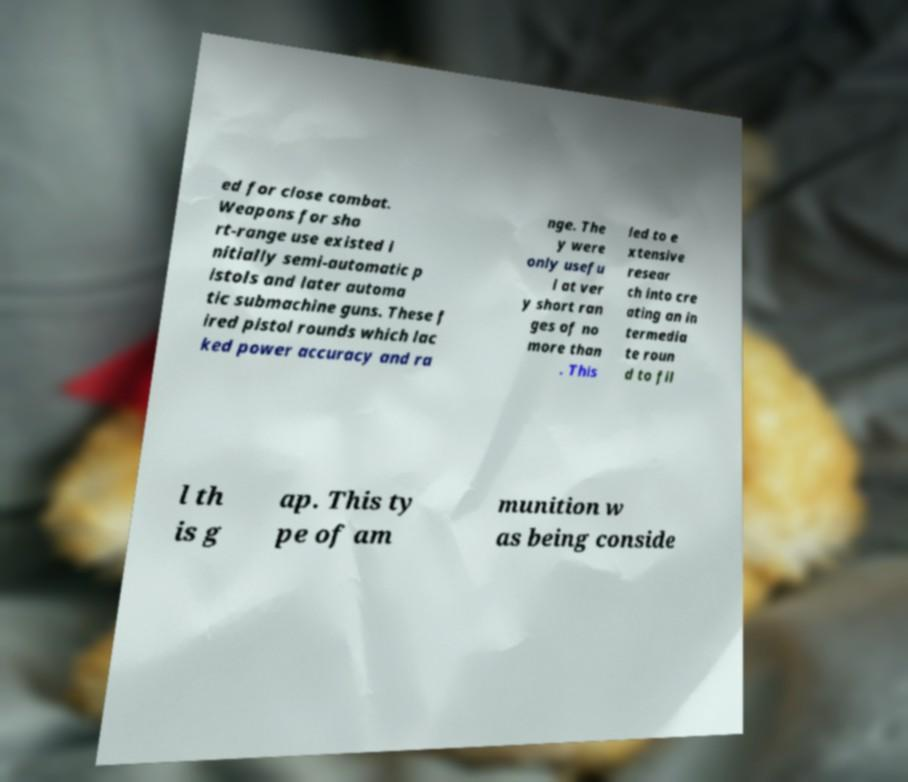Please read and relay the text visible in this image. What does it say? ed for close combat. Weapons for sho rt-range use existed i nitially semi-automatic p istols and later automa tic submachine guns. These f ired pistol rounds which lac ked power accuracy and ra nge. The y were only usefu l at ver y short ran ges of no more than . This led to e xtensive resear ch into cre ating an in termedia te roun d to fil l th is g ap. This ty pe of am munition w as being conside 